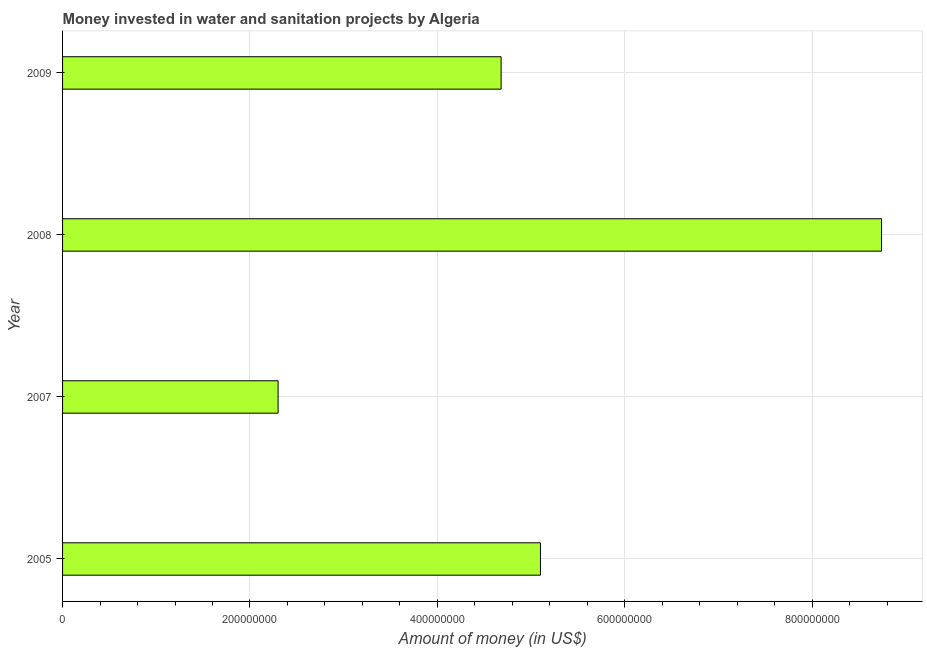What is the title of the graph?
Offer a terse response. Money invested in water and sanitation projects by Algeria. What is the label or title of the X-axis?
Ensure brevity in your answer.  Amount of money (in US$). What is the label or title of the Y-axis?
Keep it short and to the point. Year. What is the investment in 2007?
Offer a very short reply. 2.30e+08. Across all years, what is the maximum investment?
Your answer should be very brief. 8.74e+08. Across all years, what is the minimum investment?
Your answer should be very brief. 2.30e+08. In which year was the investment minimum?
Offer a terse response. 2007. What is the sum of the investment?
Your answer should be very brief. 2.08e+09. What is the difference between the investment in 2007 and 2009?
Give a very brief answer. -2.38e+08. What is the average investment per year?
Ensure brevity in your answer.  5.20e+08. What is the median investment?
Offer a terse response. 4.89e+08. In how many years, is the investment greater than 320000000 US$?
Keep it short and to the point. 3. What is the ratio of the investment in 2007 to that in 2009?
Keep it short and to the point. 0.49. Is the investment in 2007 less than that in 2009?
Provide a short and direct response. Yes. Is the difference between the investment in 2008 and 2009 greater than the difference between any two years?
Give a very brief answer. No. What is the difference between the highest and the second highest investment?
Offer a very short reply. 3.64e+08. Is the sum of the investment in 2005 and 2009 greater than the maximum investment across all years?
Give a very brief answer. Yes. What is the difference between the highest and the lowest investment?
Offer a very short reply. 6.44e+08. In how many years, is the investment greater than the average investment taken over all years?
Provide a succinct answer. 1. How many bars are there?
Your response must be concise. 4. How many years are there in the graph?
Your response must be concise. 4. What is the Amount of money (in US$) in 2005?
Make the answer very short. 5.10e+08. What is the Amount of money (in US$) of 2007?
Provide a short and direct response. 2.30e+08. What is the Amount of money (in US$) of 2008?
Provide a short and direct response. 8.74e+08. What is the Amount of money (in US$) of 2009?
Provide a short and direct response. 4.68e+08. What is the difference between the Amount of money (in US$) in 2005 and 2007?
Give a very brief answer. 2.80e+08. What is the difference between the Amount of money (in US$) in 2005 and 2008?
Ensure brevity in your answer.  -3.64e+08. What is the difference between the Amount of money (in US$) in 2005 and 2009?
Make the answer very short. 4.20e+07. What is the difference between the Amount of money (in US$) in 2007 and 2008?
Keep it short and to the point. -6.44e+08. What is the difference between the Amount of money (in US$) in 2007 and 2009?
Your answer should be very brief. -2.38e+08. What is the difference between the Amount of money (in US$) in 2008 and 2009?
Ensure brevity in your answer.  4.06e+08. What is the ratio of the Amount of money (in US$) in 2005 to that in 2007?
Make the answer very short. 2.22. What is the ratio of the Amount of money (in US$) in 2005 to that in 2008?
Provide a succinct answer. 0.58. What is the ratio of the Amount of money (in US$) in 2005 to that in 2009?
Give a very brief answer. 1.09. What is the ratio of the Amount of money (in US$) in 2007 to that in 2008?
Offer a very short reply. 0.26. What is the ratio of the Amount of money (in US$) in 2007 to that in 2009?
Your response must be concise. 0.49. What is the ratio of the Amount of money (in US$) in 2008 to that in 2009?
Give a very brief answer. 1.87. 